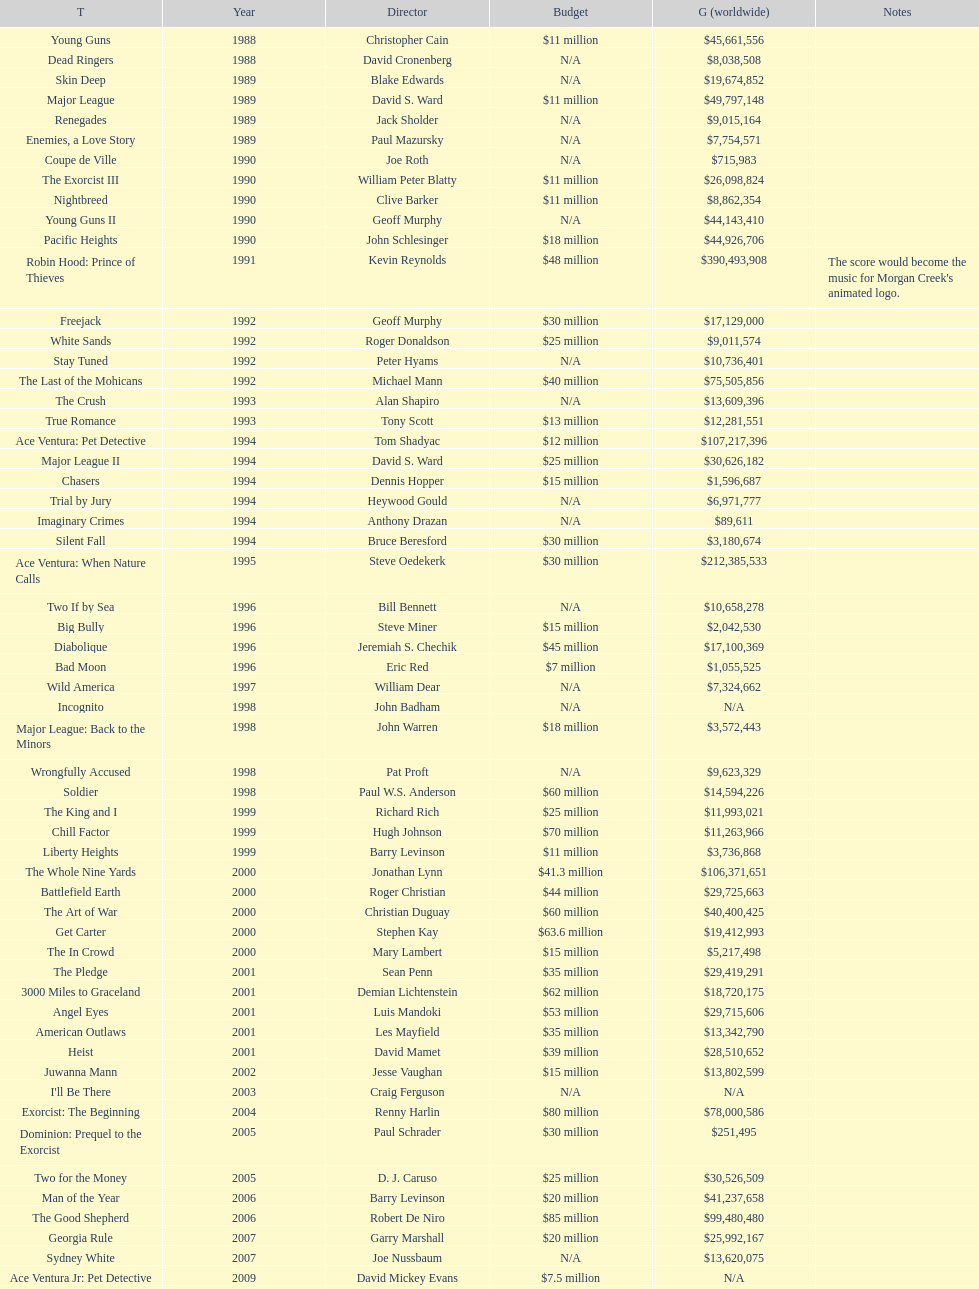What movie came out after bad moon? Wild America. 